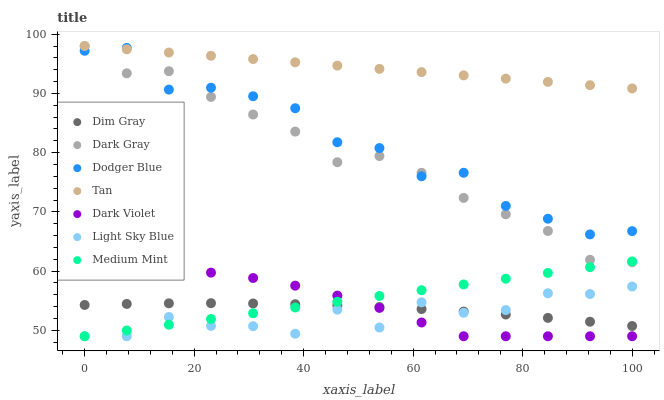Does Light Sky Blue have the minimum area under the curve?
Answer yes or no. Yes. Does Tan have the maximum area under the curve?
Answer yes or no. Yes. Does Dim Gray have the minimum area under the curve?
Answer yes or no. No. Does Dim Gray have the maximum area under the curve?
Answer yes or no. No. Is Medium Mint the smoothest?
Answer yes or no. Yes. Is Dodger Blue the roughest?
Answer yes or no. Yes. Is Dim Gray the smoothest?
Answer yes or no. No. Is Dim Gray the roughest?
Answer yes or no. No. Does Medium Mint have the lowest value?
Answer yes or no. Yes. Does Dim Gray have the lowest value?
Answer yes or no. No. Does Tan have the highest value?
Answer yes or no. Yes. Does Dark Violet have the highest value?
Answer yes or no. No. Is Light Sky Blue less than Tan?
Answer yes or no. Yes. Is Tan greater than Dark Violet?
Answer yes or no. Yes. Does Medium Mint intersect Dark Gray?
Answer yes or no. Yes. Is Medium Mint less than Dark Gray?
Answer yes or no. No. Is Medium Mint greater than Dark Gray?
Answer yes or no. No. Does Light Sky Blue intersect Tan?
Answer yes or no. No. 